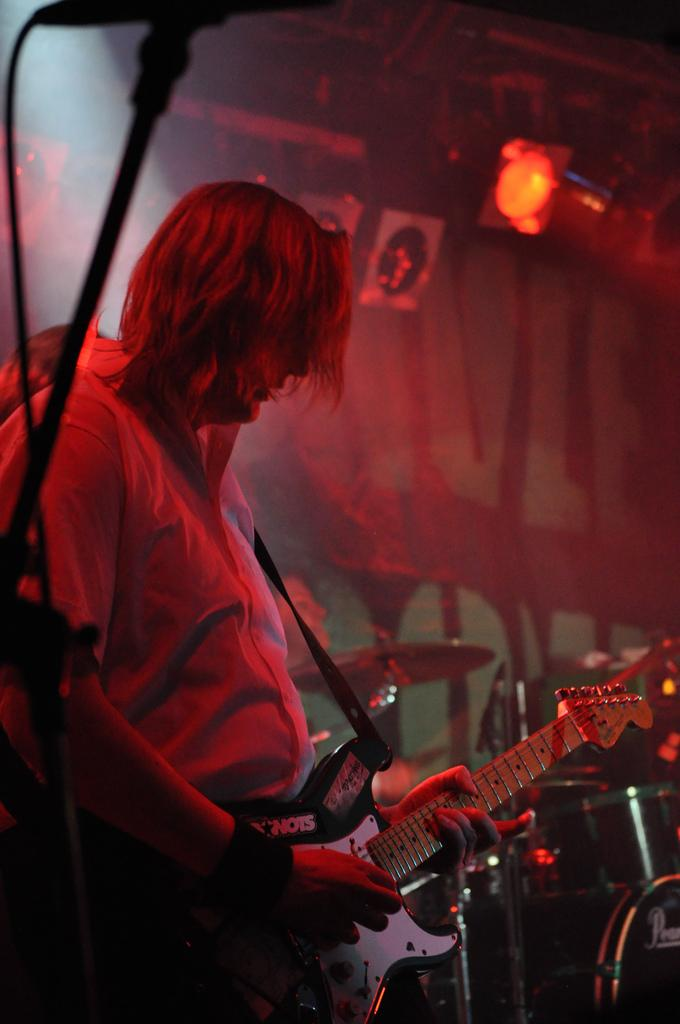What is the person in the image doing? The person is playing a guitar in the image. What is the person wearing? The person is wearing clothes in the image. What can be seen at the top of the image? There is a light at the top of the image. What other musical instruments are present in the image? There are musical instruments in the bottom right of the image. How many babies are crawling on the floor in the image? There are no babies present in the image; it features a person playing a guitar and other musical instruments. 